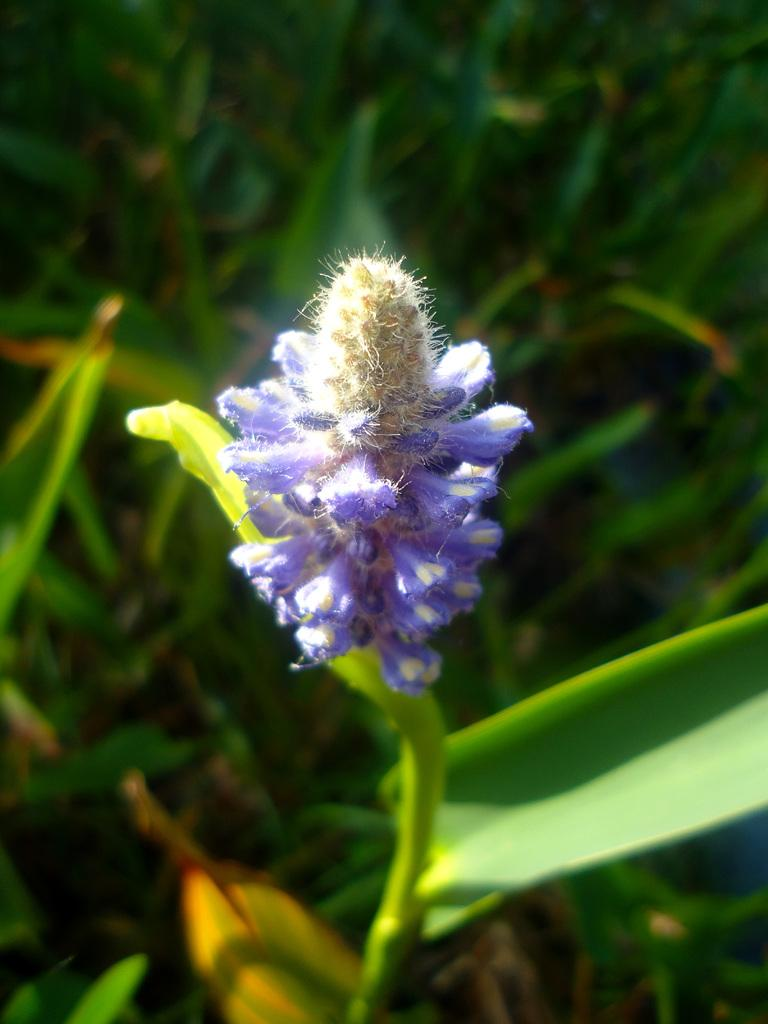What type of flower is present in the image? There is a purple and white color flower in the image. What color are the leaves surrounding the flower? The leaves visible in the image are green in color. What type of rake is used to copy the things in the image? There is no rake or copying activity present in the image; it features a flower and green leaves. 